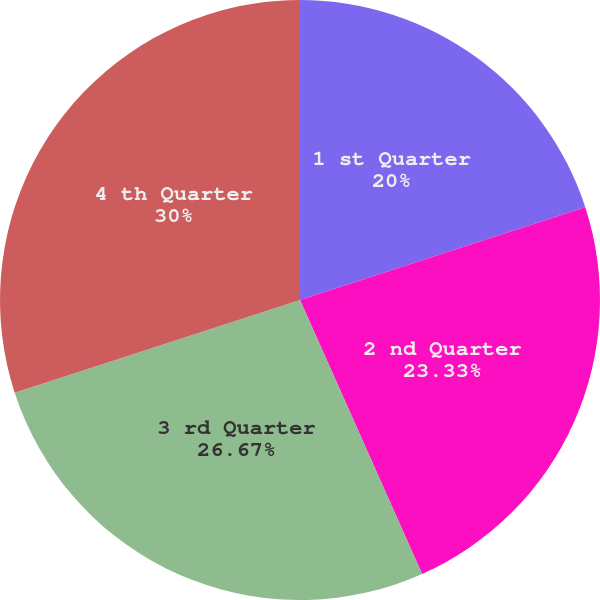Convert chart to OTSL. <chart><loc_0><loc_0><loc_500><loc_500><pie_chart><fcel>1 st Quarter<fcel>2 nd Quarter<fcel>3 rd Quarter<fcel>4 th Quarter<nl><fcel>20.0%<fcel>23.33%<fcel>26.67%<fcel>30.0%<nl></chart> 